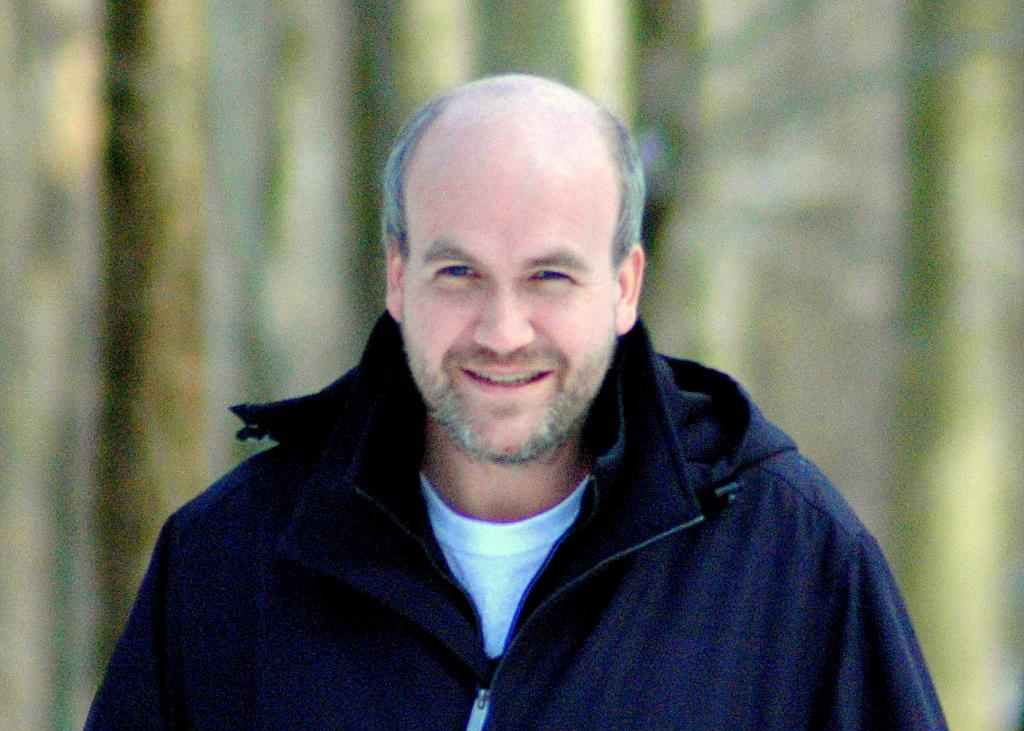Who is the main subject in the image? There is a man in the image. Where is the man located in the image? The man is in the middle of the image. What is the man wearing in the image? The man is wearing a blue jacket. Can you see the man's tail in the image? There is no tail visible in the image, as the man is a human and humans do not have tails. 